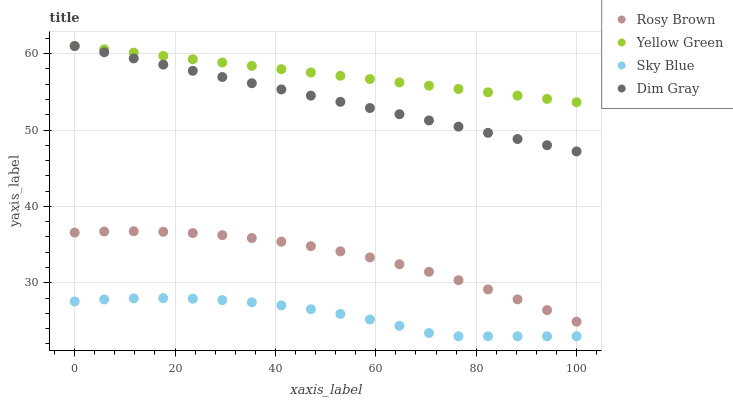Does Sky Blue have the minimum area under the curve?
Answer yes or no. Yes. Does Yellow Green have the maximum area under the curve?
Answer yes or no. Yes. Does Dim Gray have the minimum area under the curve?
Answer yes or no. No. Does Dim Gray have the maximum area under the curve?
Answer yes or no. No. Is Yellow Green the smoothest?
Answer yes or no. Yes. Is Sky Blue the roughest?
Answer yes or no. Yes. Is Dim Gray the smoothest?
Answer yes or no. No. Is Dim Gray the roughest?
Answer yes or no. No. Does Sky Blue have the lowest value?
Answer yes or no. Yes. Does Dim Gray have the lowest value?
Answer yes or no. No. Does Yellow Green have the highest value?
Answer yes or no. Yes. Does Rosy Brown have the highest value?
Answer yes or no. No. Is Rosy Brown less than Dim Gray?
Answer yes or no. Yes. Is Yellow Green greater than Rosy Brown?
Answer yes or no. Yes. Does Dim Gray intersect Yellow Green?
Answer yes or no. Yes. Is Dim Gray less than Yellow Green?
Answer yes or no. No. Is Dim Gray greater than Yellow Green?
Answer yes or no. No. Does Rosy Brown intersect Dim Gray?
Answer yes or no. No. 